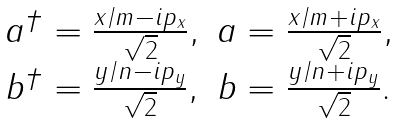<formula> <loc_0><loc_0><loc_500><loc_500>\begin{array} { c c } a ^ { \dagger } = \frac { x / m - i p _ { x } } { \sqrt { 2 } } , & a = \frac { x / m + i p _ { x } } { \sqrt { 2 } } , \\ b ^ { \dagger } = \frac { y / n - i p _ { y } } { \sqrt { 2 } } , & b = \frac { y / n + i p _ { y } } { \sqrt { 2 } } . \end{array}</formula> 